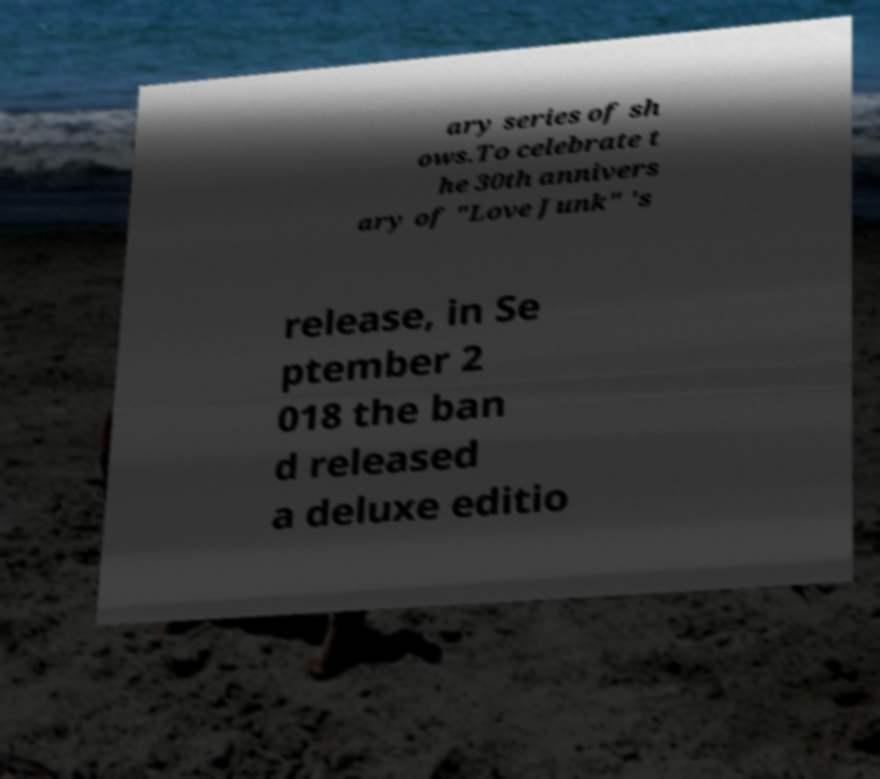For documentation purposes, I need the text within this image transcribed. Could you provide that? ary series of sh ows.To celebrate t he 30th annivers ary of "Love Junk" 's release, in Se ptember 2 018 the ban d released a deluxe editio 